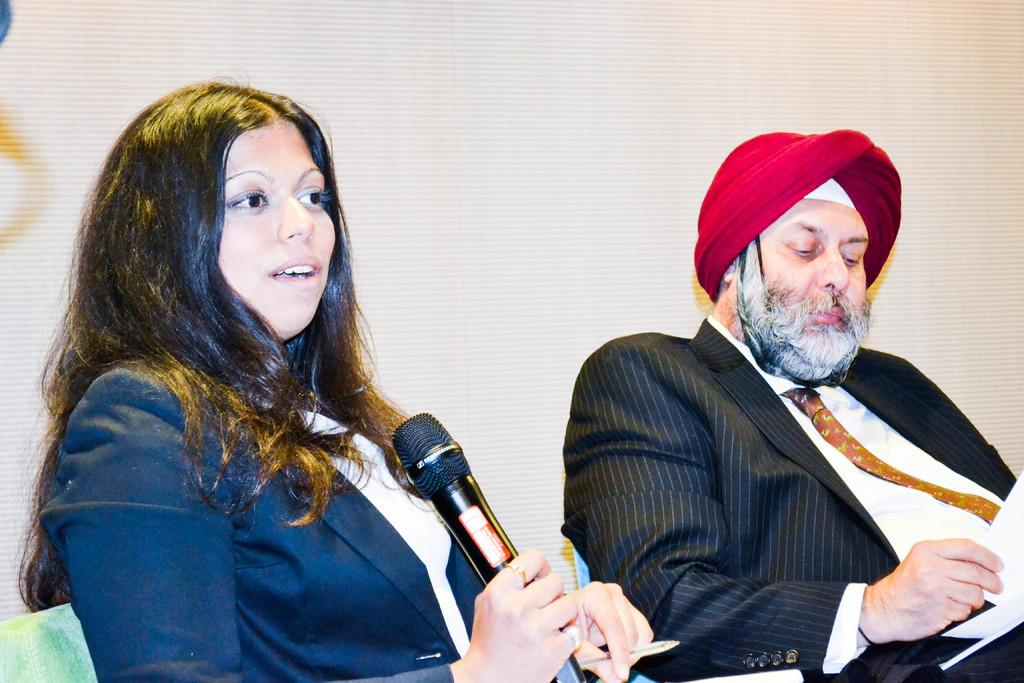Who is the main subject in the image? There is a woman in the image. What is the woman doing in the image? The woman is sitting on a chair and holding a microphone. Is there anyone else in the image? Yes, there is a person sitting beside the woman. What is the person beside the woman holding? The person is holding papers in his hand. What type of rail can be seen in the image? There is no rail present in the image. Can you describe the marble texture on the microphone in the image? The microphone in the image does not have a marble texture; it is not mentioned in the provided facts. 